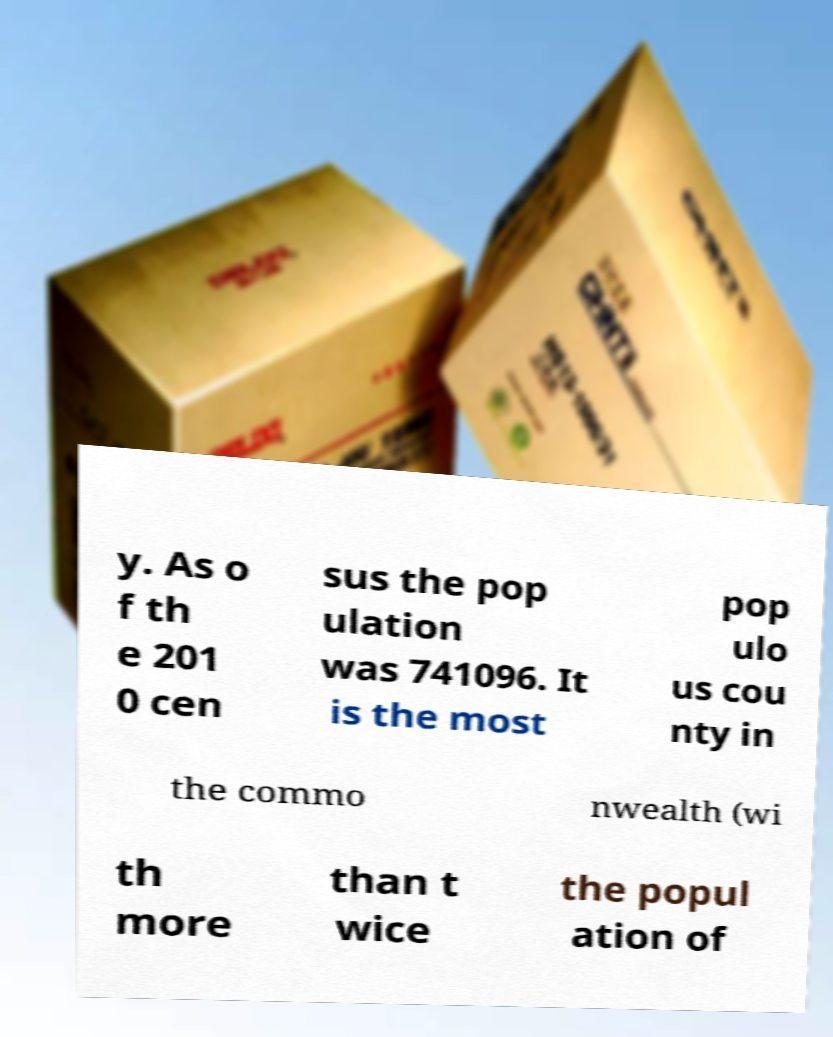Could you extract and type out the text from this image? y. As o f th e 201 0 cen sus the pop ulation was 741096. It is the most pop ulo us cou nty in the commo nwealth (wi th more than t wice the popul ation of 